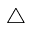Convert formula to latex. <formula><loc_0><loc_0><loc_500><loc_500>\triangle</formula> 